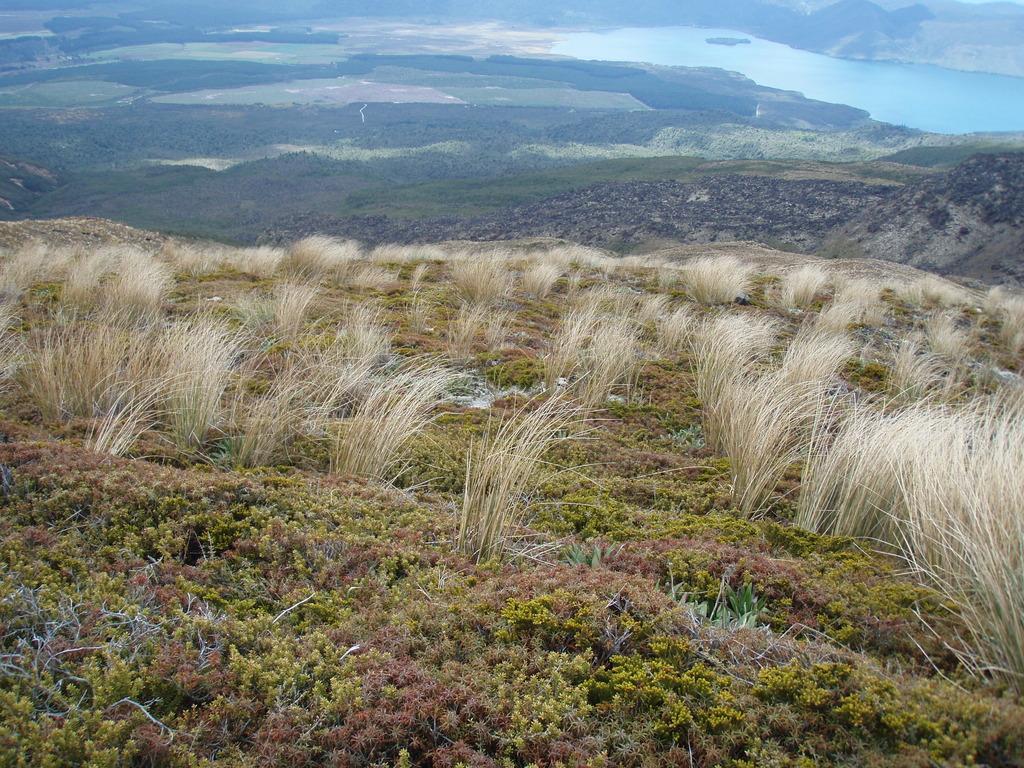In one or two sentences, can you explain what this image depicts? In this image, we can see so many plants. Background we can see a grass and water. 